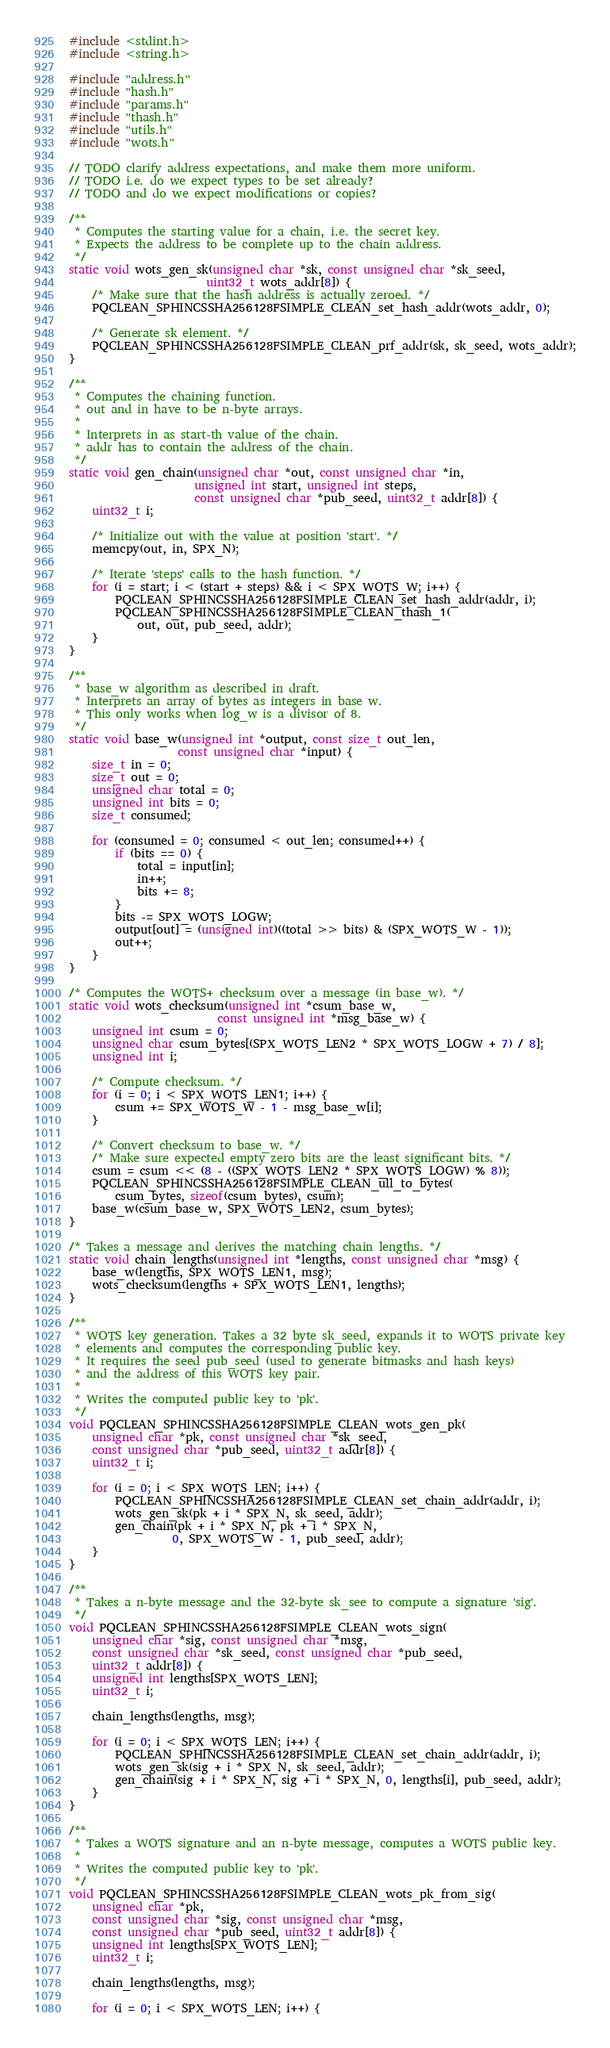Convert code to text. <code><loc_0><loc_0><loc_500><loc_500><_C_>#include <stdint.h>
#include <string.h>

#include "address.h"
#include "hash.h"
#include "params.h"
#include "thash.h"
#include "utils.h"
#include "wots.h"

// TODO clarify address expectations, and make them more uniform.
// TODO i.e. do we expect types to be set already?
// TODO and do we expect modifications or copies?

/**
 * Computes the starting value for a chain, i.e. the secret key.
 * Expects the address to be complete up to the chain address.
 */
static void wots_gen_sk(unsigned char *sk, const unsigned char *sk_seed,
                        uint32_t wots_addr[8]) {
    /* Make sure that the hash address is actually zeroed. */
    PQCLEAN_SPHINCSSHA256128FSIMPLE_CLEAN_set_hash_addr(wots_addr, 0);

    /* Generate sk element. */
    PQCLEAN_SPHINCSSHA256128FSIMPLE_CLEAN_prf_addr(sk, sk_seed, wots_addr);
}

/**
 * Computes the chaining function.
 * out and in have to be n-byte arrays.
 *
 * Interprets in as start-th value of the chain.
 * addr has to contain the address of the chain.
 */
static void gen_chain(unsigned char *out, const unsigned char *in,
                      unsigned int start, unsigned int steps,
                      const unsigned char *pub_seed, uint32_t addr[8]) {
    uint32_t i;

    /* Initialize out with the value at position 'start'. */
    memcpy(out, in, SPX_N);

    /* Iterate 'steps' calls to the hash function. */
    for (i = start; i < (start + steps) && i < SPX_WOTS_W; i++) {
        PQCLEAN_SPHINCSSHA256128FSIMPLE_CLEAN_set_hash_addr(addr, i);
        PQCLEAN_SPHINCSSHA256128FSIMPLE_CLEAN_thash_1(
            out, out, pub_seed, addr);
    }
}

/**
 * base_w algorithm as described in draft.
 * Interprets an array of bytes as integers in base w.
 * This only works when log_w is a divisor of 8.
 */
static void base_w(unsigned int *output, const size_t out_len,
                   const unsigned char *input) {
    size_t in = 0;
    size_t out = 0;
    unsigned char total = 0;
    unsigned int bits = 0;
    size_t consumed;

    for (consumed = 0; consumed < out_len; consumed++) {
        if (bits == 0) {
            total = input[in];
            in++;
            bits += 8;
        }
        bits -= SPX_WOTS_LOGW;
        output[out] = (unsigned int)((total >> bits) & (SPX_WOTS_W - 1));
        out++;
    }
}

/* Computes the WOTS+ checksum over a message (in base_w). */
static void wots_checksum(unsigned int *csum_base_w,
                          const unsigned int *msg_base_w) {
    unsigned int csum = 0;
    unsigned char csum_bytes[(SPX_WOTS_LEN2 * SPX_WOTS_LOGW + 7) / 8];
    unsigned int i;

    /* Compute checksum. */
    for (i = 0; i < SPX_WOTS_LEN1; i++) {
        csum += SPX_WOTS_W - 1 - msg_base_w[i];
    }

    /* Convert checksum to base_w. */
    /* Make sure expected empty zero bits are the least significant bits. */
    csum = csum << (8 - ((SPX_WOTS_LEN2 * SPX_WOTS_LOGW) % 8));
    PQCLEAN_SPHINCSSHA256128FSIMPLE_CLEAN_ull_to_bytes(
        csum_bytes, sizeof(csum_bytes), csum);
    base_w(csum_base_w, SPX_WOTS_LEN2, csum_bytes);
}

/* Takes a message and derives the matching chain lengths. */
static void chain_lengths(unsigned int *lengths, const unsigned char *msg) {
    base_w(lengths, SPX_WOTS_LEN1, msg);
    wots_checksum(lengths + SPX_WOTS_LEN1, lengths);
}

/**
 * WOTS key generation. Takes a 32 byte sk_seed, expands it to WOTS private key
 * elements and computes the corresponding public key.
 * It requires the seed pub_seed (used to generate bitmasks and hash keys)
 * and the address of this WOTS key pair.
 *
 * Writes the computed public key to 'pk'.
 */
void PQCLEAN_SPHINCSSHA256128FSIMPLE_CLEAN_wots_gen_pk(
    unsigned char *pk, const unsigned char *sk_seed,
    const unsigned char *pub_seed, uint32_t addr[8]) {
    uint32_t i;

    for (i = 0; i < SPX_WOTS_LEN; i++) {
        PQCLEAN_SPHINCSSHA256128FSIMPLE_CLEAN_set_chain_addr(addr, i);
        wots_gen_sk(pk + i * SPX_N, sk_seed, addr);
        gen_chain(pk + i * SPX_N, pk + i * SPX_N,
                  0, SPX_WOTS_W - 1, pub_seed, addr);
    }
}

/**
 * Takes a n-byte message and the 32-byte sk_see to compute a signature 'sig'.
 */
void PQCLEAN_SPHINCSSHA256128FSIMPLE_CLEAN_wots_sign(
    unsigned char *sig, const unsigned char *msg,
    const unsigned char *sk_seed, const unsigned char *pub_seed,
    uint32_t addr[8]) {
    unsigned int lengths[SPX_WOTS_LEN];
    uint32_t i;

    chain_lengths(lengths, msg);

    for (i = 0; i < SPX_WOTS_LEN; i++) {
        PQCLEAN_SPHINCSSHA256128FSIMPLE_CLEAN_set_chain_addr(addr, i);
        wots_gen_sk(sig + i * SPX_N, sk_seed, addr);
        gen_chain(sig + i * SPX_N, sig + i * SPX_N, 0, lengths[i], pub_seed, addr);
    }
}

/**
 * Takes a WOTS signature and an n-byte message, computes a WOTS public key.
 *
 * Writes the computed public key to 'pk'.
 */
void PQCLEAN_SPHINCSSHA256128FSIMPLE_CLEAN_wots_pk_from_sig(
    unsigned char *pk,
    const unsigned char *sig, const unsigned char *msg,
    const unsigned char *pub_seed, uint32_t addr[8]) {
    unsigned int lengths[SPX_WOTS_LEN];
    uint32_t i;

    chain_lengths(lengths, msg);

    for (i = 0; i < SPX_WOTS_LEN; i++) {</code> 